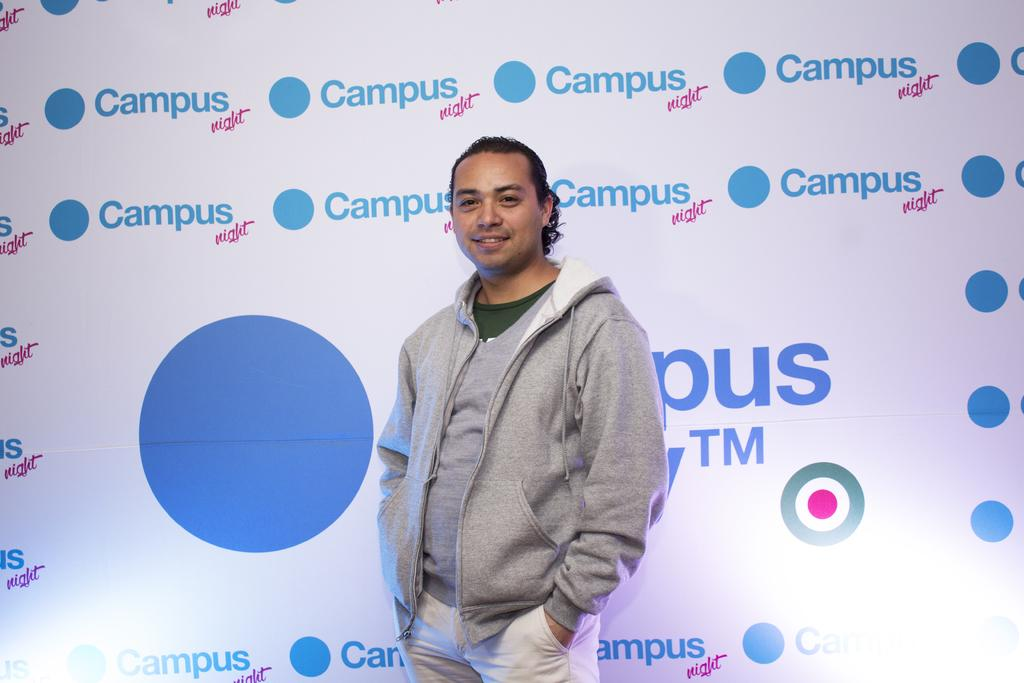Who is present in the image? There is a man in the image. What is the man wearing? The man is wearing a gray jacket. Where is the man positioned in the image? The man is standing in the middle of the image. What can be seen in the background of the image? There is a hoarding in the background of the image. What type of wax is being used by the man in the image? There is no wax present in the image, and the man is not using any wax. What is the man's state of mind in the image? The image does not provide any information about the man's state of mind. 